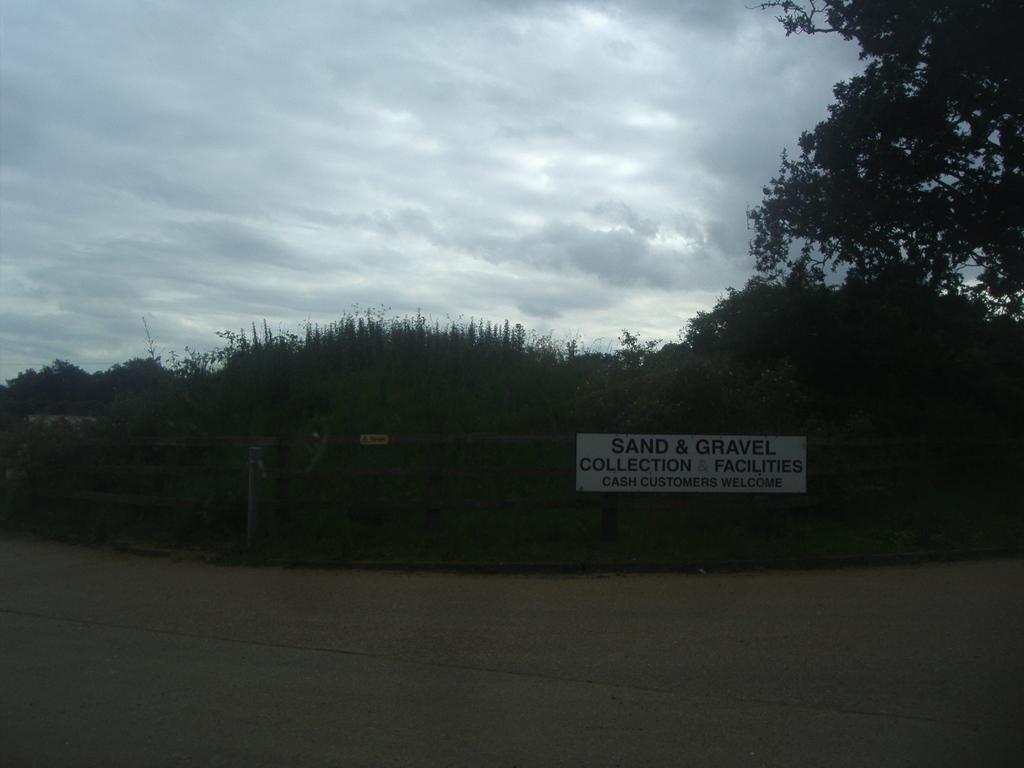How would you summarize this image in a sentence or two? In this picture we can see the road and in the background we can see a fence, board, trees and the sky. 